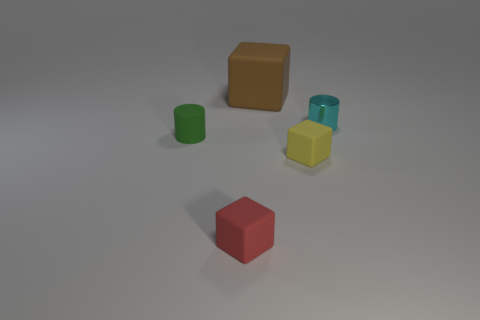Subtract all large blocks. How many blocks are left? 2 Subtract all yellow cubes. How many cubes are left? 2 Subtract 1 cylinders. How many cylinders are left? 1 Add 3 big brown rubber cubes. How many objects exist? 8 Subtract all cubes. How many objects are left? 2 Subtract all cyan spheres. How many green cylinders are left? 1 Subtract all red cubes. Subtract all yellow cylinders. How many cubes are left? 2 Add 1 big metallic blocks. How many big metallic blocks exist? 1 Subtract 0 cyan cubes. How many objects are left? 5 Subtract all big red metallic blocks. Subtract all metal cylinders. How many objects are left? 4 